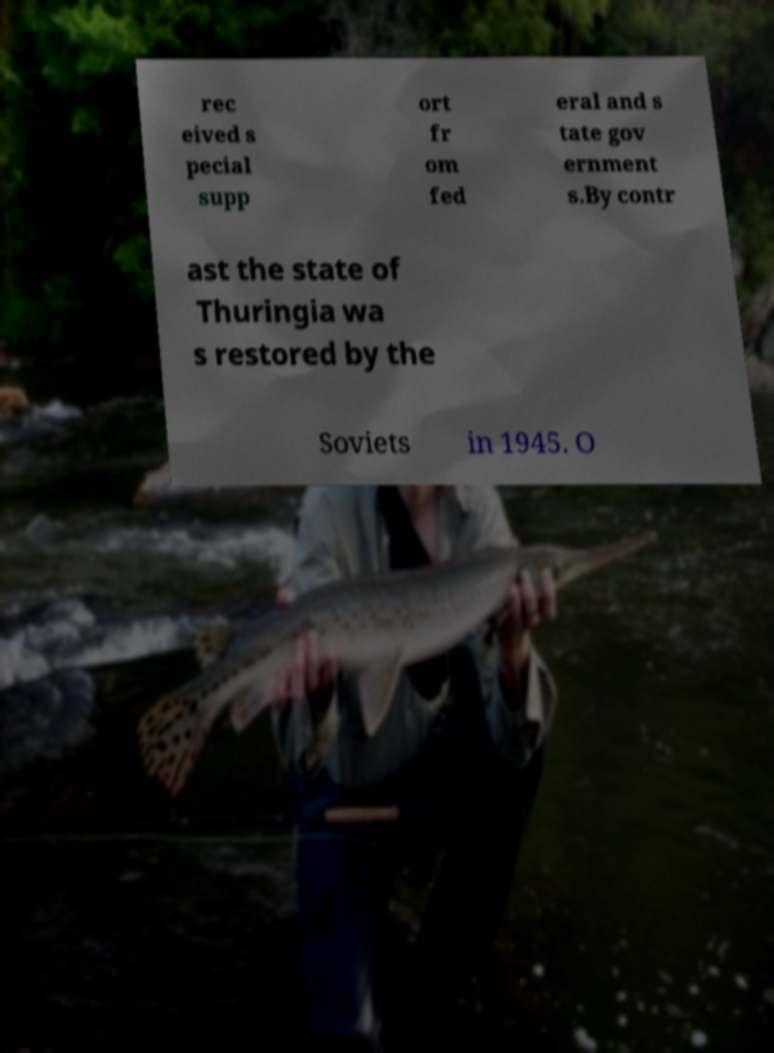Please identify and transcribe the text found in this image. rec eived s pecial supp ort fr om fed eral and s tate gov ernment s.By contr ast the state of Thuringia wa s restored by the Soviets in 1945. O 